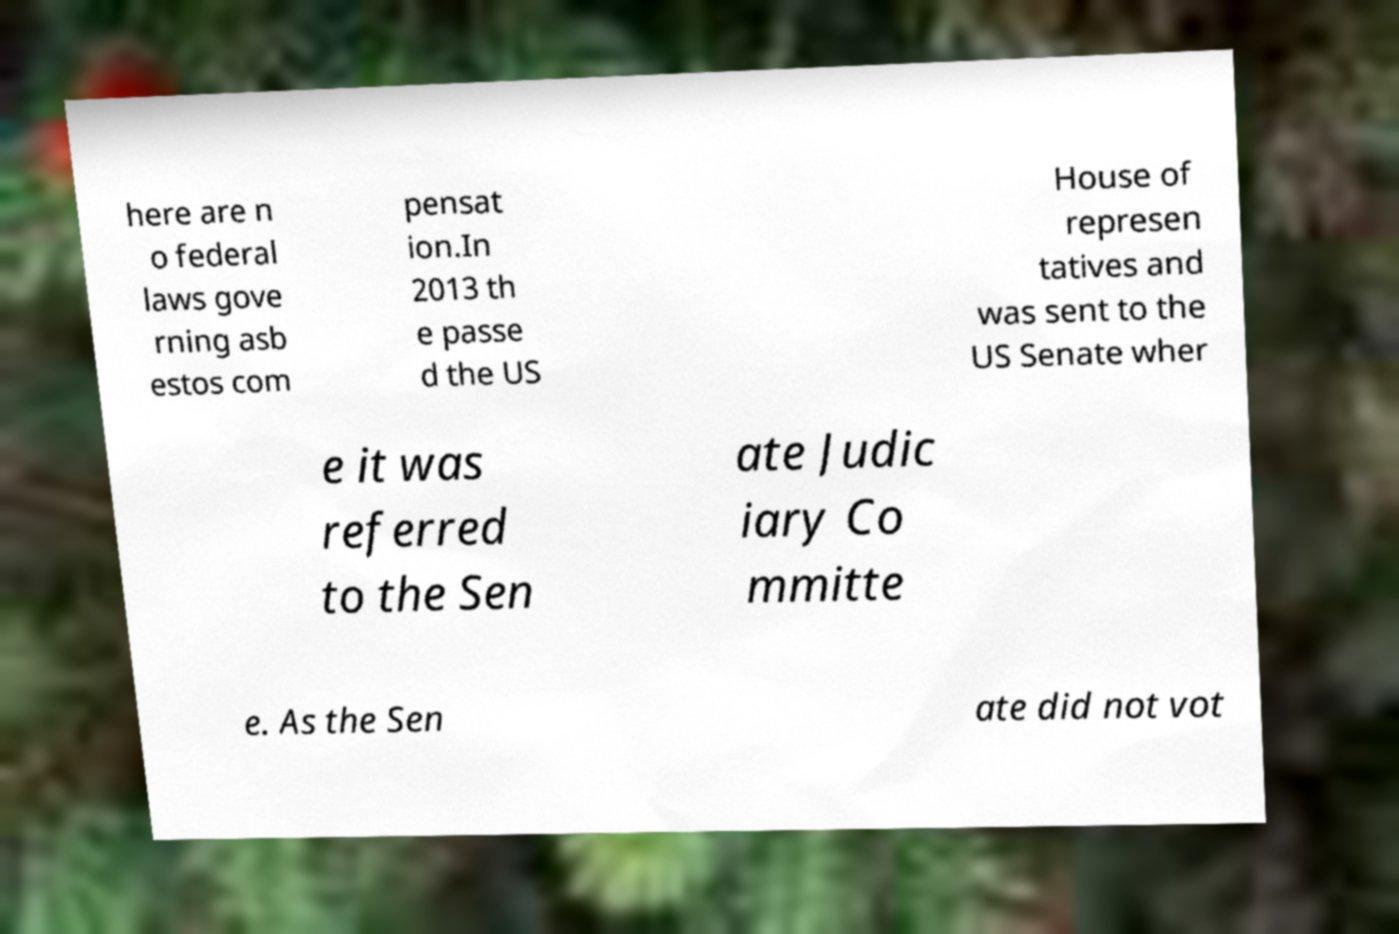Please read and relay the text visible in this image. What does it say? here are n o federal laws gove rning asb estos com pensat ion.In 2013 th e passe d the US House of represen tatives and was sent to the US Senate wher e it was referred to the Sen ate Judic iary Co mmitte e. As the Sen ate did not vot 